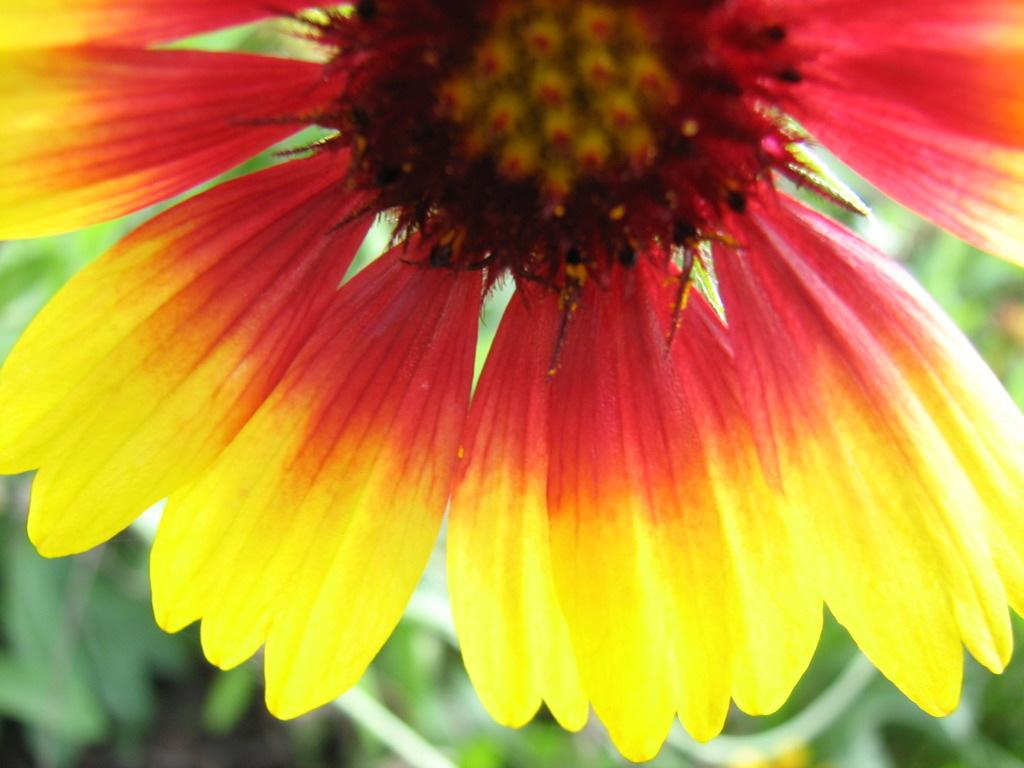What is the main subject of the picture? There is a flower in the picture. What can be seen in the background of the picture? There are leaves in the background of the picture. What color is the shirt worn by the cat in the picture? There is no cat or shirt present in the picture; it features a flower and leaves. What type of soap is used to clean the flower in the picture? There is no soap or cleaning activity depicted in the picture; it simply shows a flower and leaves. 